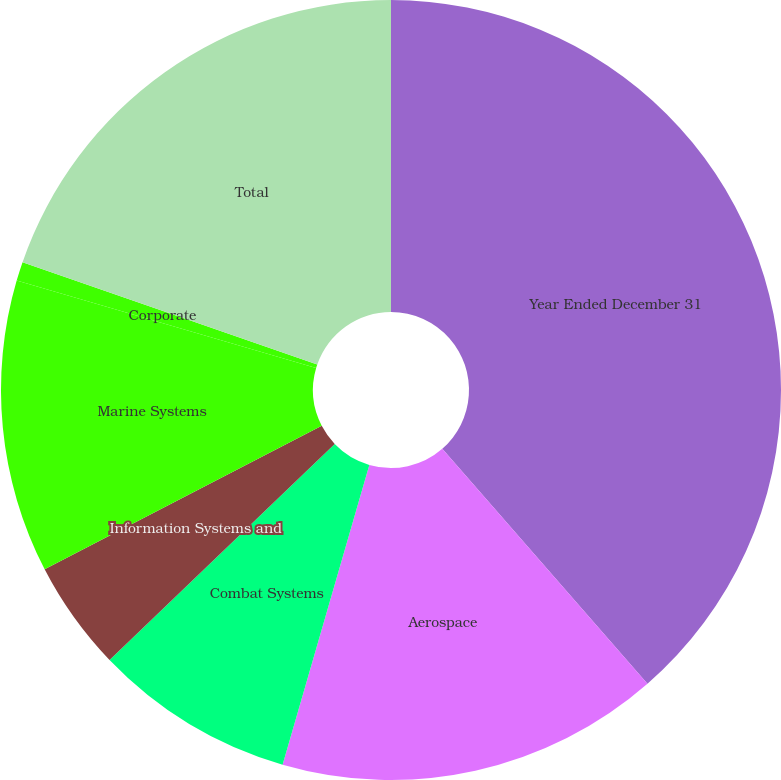<chart> <loc_0><loc_0><loc_500><loc_500><pie_chart><fcel>Year Ended December 31<fcel>Aerospace<fcel>Combat Systems<fcel>Information Systems and<fcel>Marine Systems<fcel>Corporate<fcel>Total<nl><fcel>38.59%<fcel>15.91%<fcel>8.35%<fcel>4.57%<fcel>12.13%<fcel>0.79%<fcel>19.69%<nl></chart> 